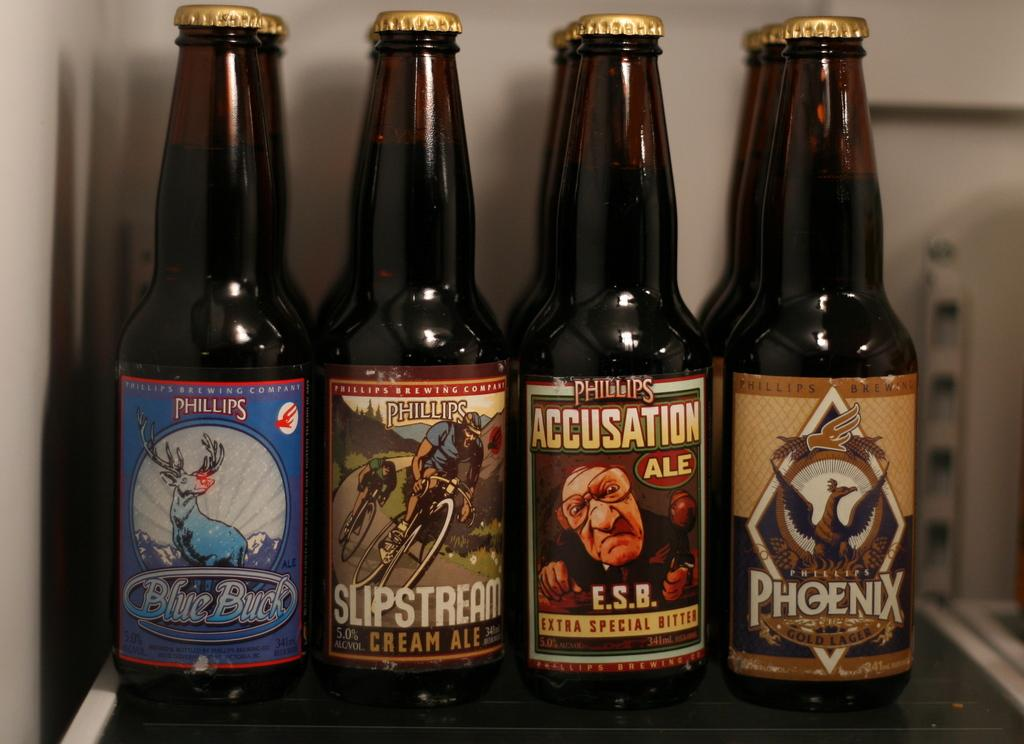Provide a one-sentence caption for the provided image. Four closed black bottles by the brand Phillips. 